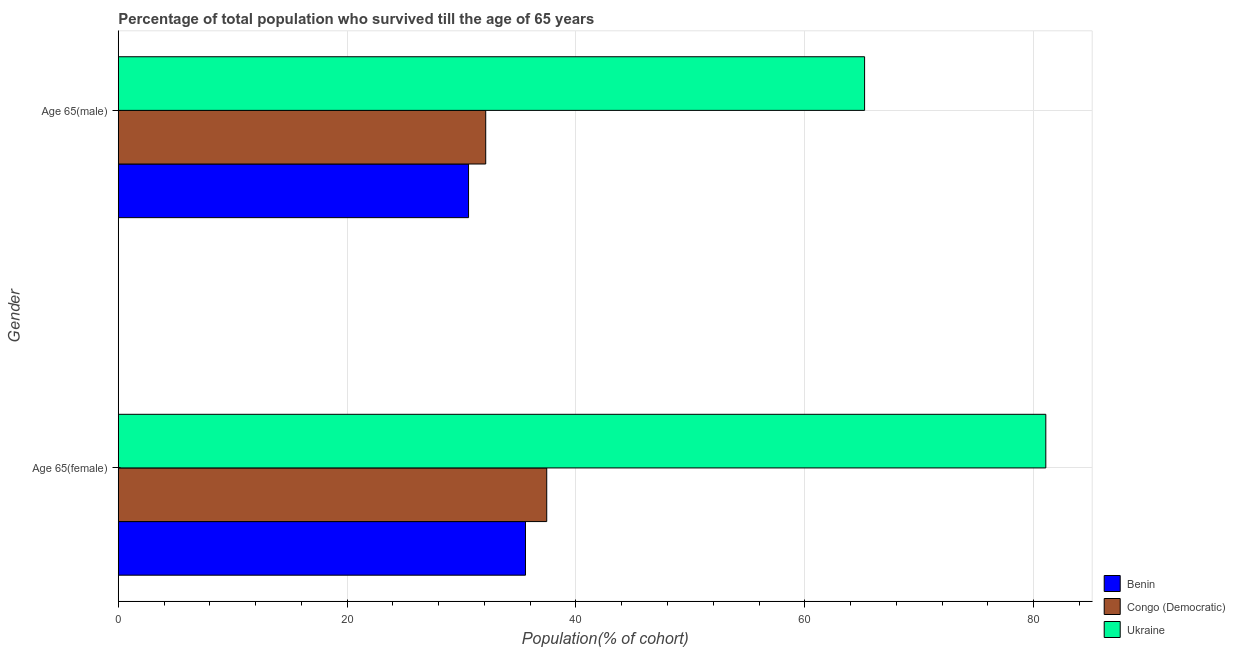How many different coloured bars are there?
Your response must be concise. 3. How many groups of bars are there?
Your response must be concise. 2. How many bars are there on the 1st tick from the bottom?
Offer a very short reply. 3. What is the label of the 1st group of bars from the top?
Provide a succinct answer. Age 65(male). What is the percentage of male population who survived till age of 65 in Benin?
Offer a terse response. 30.61. Across all countries, what is the maximum percentage of female population who survived till age of 65?
Provide a succinct answer. 81.07. Across all countries, what is the minimum percentage of female population who survived till age of 65?
Ensure brevity in your answer.  35.59. In which country was the percentage of male population who survived till age of 65 maximum?
Your response must be concise. Ukraine. In which country was the percentage of male population who survived till age of 65 minimum?
Keep it short and to the point. Benin. What is the total percentage of male population who survived till age of 65 in the graph?
Your response must be concise. 127.95. What is the difference between the percentage of female population who survived till age of 65 in Ukraine and that in Congo (Democratic)?
Your answer should be compact. 43.62. What is the difference between the percentage of male population who survived till age of 65 in Benin and the percentage of female population who survived till age of 65 in Congo (Democratic)?
Your answer should be compact. -6.83. What is the average percentage of female population who survived till age of 65 per country?
Give a very brief answer. 51.37. What is the difference between the percentage of female population who survived till age of 65 and percentage of male population who survived till age of 65 in Congo (Democratic)?
Keep it short and to the point. 5.33. What is the ratio of the percentage of female population who survived till age of 65 in Congo (Democratic) to that in Ukraine?
Keep it short and to the point. 0.46. What does the 1st bar from the top in Age 65(female) represents?
Offer a terse response. Ukraine. What does the 3rd bar from the bottom in Age 65(female) represents?
Your answer should be compact. Ukraine. How many bars are there?
Make the answer very short. 6. Are all the bars in the graph horizontal?
Your answer should be compact. Yes. How many countries are there in the graph?
Your response must be concise. 3. Where does the legend appear in the graph?
Your answer should be compact. Bottom right. How many legend labels are there?
Your answer should be very brief. 3. How are the legend labels stacked?
Your response must be concise. Vertical. What is the title of the graph?
Provide a succinct answer. Percentage of total population who survived till the age of 65 years. What is the label or title of the X-axis?
Keep it short and to the point. Population(% of cohort). What is the Population(% of cohort) in Benin in Age 65(female)?
Offer a terse response. 35.59. What is the Population(% of cohort) in Congo (Democratic) in Age 65(female)?
Your answer should be compact. 37.45. What is the Population(% of cohort) of Ukraine in Age 65(female)?
Give a very brief answer. 81.07. What is the Population(% of cohort) in Benin in Age 65(male)?
Make the answer very short. 30.61. What is the Population(% of cohort) of Congo (Democratic) in Age 65(male)?
Offer a terse response. 32.11. What is the Population(% of cohort) of Ukraine in Age 65(male)?
Make the answer very short. 65.23. Across all Gender, what is the maximum Population(% of cohort) in Benin?
Your answer should be very brief. 35.59. Across all Gender, what is the maximum Population(% of cohort) of Congo (Democratic)?
Provide a succinct answer. 37.45. Across all Gender, what is the maximum Population(% of cohort) of Ukraine?
Offer a very short reply. 81.07. Across all Gender, what is the minimum Population(% of cohort) in Benin?
Your answer should be very brief. 30.61. Across all Gender, what is the minimum Population(% of cohort) of Congo (Democratic)?
Your response must be concise. 32.11. Across all Gender, what is the minimum Population(% of cohort) in Ukraine?
Your response must be concise. 65.23. What is the total Population(% of cohort) of Benin in the graph?
Your response must be concise. 66.2. What is the total Population(% of cohort) in Congo (Democratic) in the graph?
Give a very brief answer. 69.56. What is the total Population(% of cohort) of Ukraine in the graph?
Your response must be concise. 146.29. What is the difference between the Population(% of cohort) of Benin in Age 65(female) and that in Age 65(male)?
Make the answer very short. 4.98. What is the difference between the Population(% of cohort) of Congo (Democratic) in Age 65(female) and that in Age 65(male)?
Make the answer very short. 5.33. What is the difference between the Population(% of cohort) in Ukraine in Age 65(female) and that in Age 65(male)?
Your answer should be very brief. 15.84. What is the difference between the Population(% of cohort) in Benin in Age 65(female) and the Population(% of cohort) in Congo (Democratic) in Age 65(male)?
Offer a terse response. 3.48. What is the difference between the Population(% of cohort) of Benin in Age 65(female) and the Population(% of cohort) of Ukraine in Age 65(male)?
Provide a short and direct response. -29.64. What is the difference between the Population(% of cohort) in Congo (Democratic) in Age 65(female) and the Population(% of cohort) in Ukraine in Age 65(male)?
Provide a short and direct response. -27.78. What is the average Population(% of cohort) in Benin per Gender?
Provide a short and direct response. 33.1. What is the average Population(% of cohort) in Congo (Democratic) per Gender?
Provide a succinct answer. 34.78. What is the average Population(% of cohort) in Ukraine per Gender?
Your response must be concise. 73.15. What is the difference between the Population(% of cohort) in Benin and Population(% of cohort) in Congo (Democratic) in Age 65(female)?
Your answer should be compact. -1.86. What is the difference between the Population(% of cohort) in Benin and Population(% of cohort) in Ukraine in Age 65(female)?
Make the answer very short. -45.48. What is the difference between the Population(% of cohort) of Congo (Democratic) and Population(% of cohort) of Ukraine in Age 65(female)?
Your answer should be compact. -43.62. What is the difference between the Population(% of cohort) in Benin and Population(% of cohort) in Congo (Democratic) in Age 65(male)?
Ensure brevity in your answer.  -1.5. What is the difference between the Population(% of cohort) in Benin and Population(% of cohort) in Ukraine in Age 65(male)?
Your response must be concise. -34.61. What is the difference between the Population(% of cohort) of Congo (Democratic) and Population(% of cohort) of Ukraine in Age 65(male)?
Give a very brief answer. -33.11. What is the ratio of the Population(% of cohort) of Benin in Age 65(female) to that in Age 65(male)?
Make the answer very short. 1.16. What is the ratio of the Population(% of cohort) of Congo (Democratic) in Age 65(female) to that in Age 65(male)?
Provide a short and direct response. 1.17. What is the ratio of the Population(% of cohort) in Ukraine in Age 65(female) to that in Age 65(male)?
Give a very brief answer. 1.24. What is the difference between the highest and the second highest Population(% of cohort) in Benin?
Make the answer very short. 4.98. What is the difference between the highest and the second highest Population(% of cohort) of Congo (Democratic)?
Offer a very short reply. 5.33. What is the difference between the highest and the second highest Population(% of cohort) of Ukraine?
Keep it short and to the point. 15.84. What is the difference between the highest and the lowest Population(% of cohort) of Benin?
Offer a terse response. 4.98. What is the difference between the highest and the lowest Population(% of cohort) of Congo (Democratic)?
Offer a very short reply. 5.33. What is the difference between the highest and the lowest Population(% of cohort) in Ukraine?
Provide a short and direct response. 15.84. 